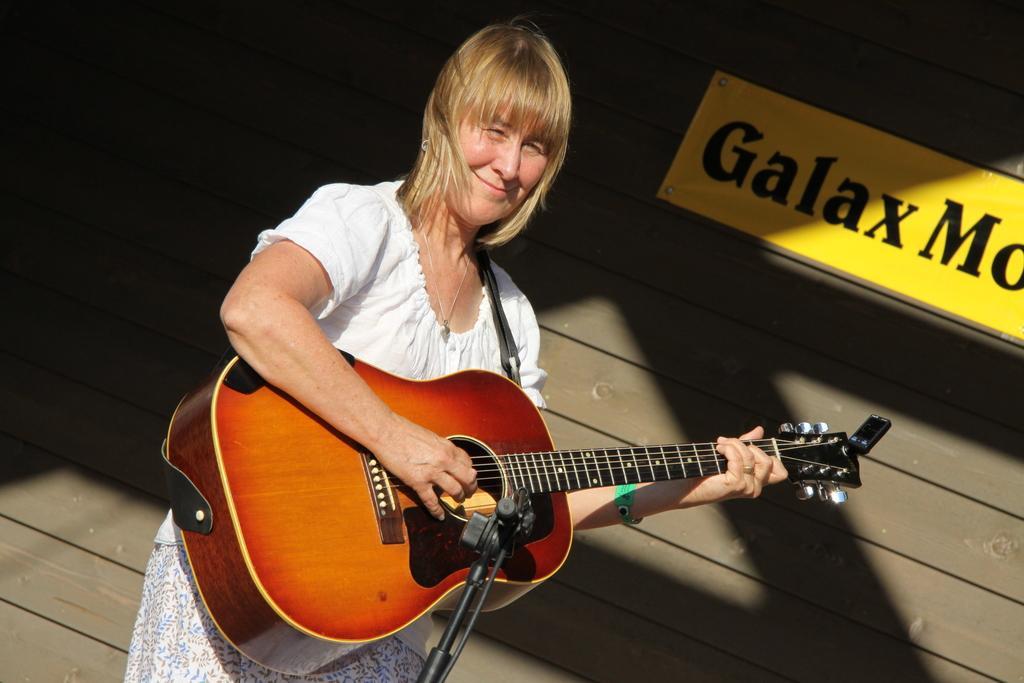Describe this image in one or two sentences. In this image i can see a woman playing guitar there is a stand in front of her at the back ground there is a board and a wooden wall. 